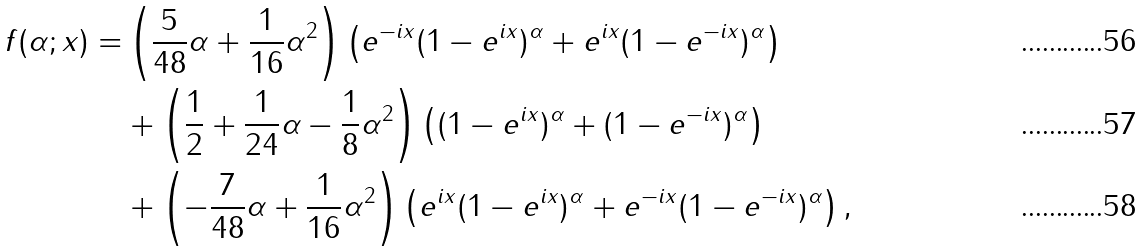<formula> <loc_0><loc_0><loc_500><loc_500>f ( \alpha ; x ) = & \left ( \frac { 5 } { 4 8 } \alpha + \frac { 1 } { 1 6 } \alpha ^ { 2 } \right ) \left ( e ^ { - i x } ( 1 - e ^ { i x } ) ^ { \alpha } + e ^ { i x } ( 1 - e ^ { - i x } ) ^ { \alpha } \right ) \\ & + \left ( \frac { 1 } { 2 } + \frac { 1 } { 2 4 } \alpha - \frac { 1 } { 8 } \alpha ^ { 2 } \right ) \left ( ( 1 - e ^ { i x } ) ^ { \alpha } + ( 1 - e ^ { - i x } ) ^ { \alpha } \right ) \\ & + \left ( - \frac { 7 } { 4 8 } \alpha + \frac { 1 } { 1 6 } \alpha ^ { 2 } \right ) \left ( e ^ { i x } ( 1 - e ^ { i x } ) ^ { \alpha } + e ^ { - i x } ( 1 - e ^ { - i x } ) ^ { \alpha } \right ) ,</formula> 